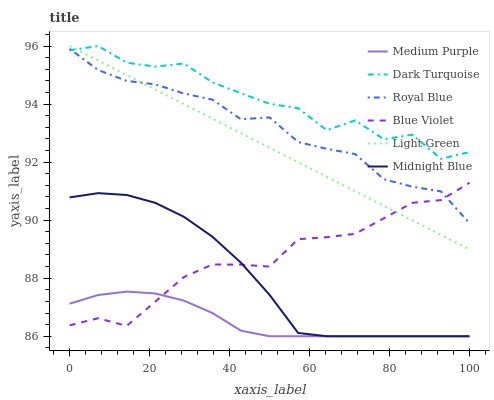Does Medium Purple have the minimum area under the curve?
Answer yes or no. Yes. Does Dark Turquoise have the maximum area under the curve?
Answer yes or no. Yes. Does Dark Turquoise have the minimum area under the curve?
Answer yes or no. No. Does Medium Purple have the maximum area under the curve?
Answer yes or no. No. Is Light Green the smoothest?
Answer yes or no. Yes. Is Dark Turquoise the roughest?
Answer yes or no. Yes. Is Medium Purple the smoothest?
Answer yes or no. No. Is Medium Purple the roughest?
Answer yes or no. No. Does Midnight Blue have the lowest value?
Answer yes or no. Yes. Does Dark Turquoise have the lowest value?
Answer yes or no. No. Does Light Green have the highest value?
Answer yes or no. Yes. Does Medium Purple have the highest value?
Answer yes or no. No. Is Medium Purple less than Royal Blue?
Answer yes or no. Yes. Is Light Green greater than Midnight Blue?
Answer yes or no. Yes. Does Medium Purple intersect Midnight Blue?
Answer yes or no. Yes. Is Medium Purple less than Midnight Blue?
Answer yes or no. No. Is Medium Purple greater than Midnight Blue?
Answer yes or no. No. Does Medium Purple intersect Royal Blue?
Answer yes or no. No. 